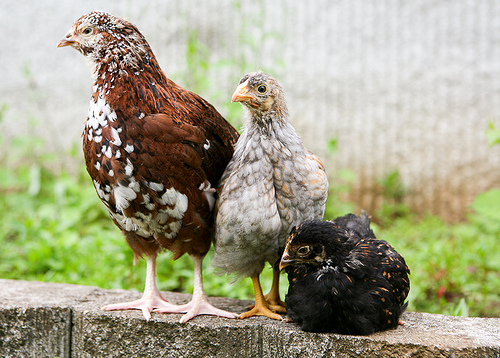<image>
Can you confirm if the chicken is to the right of the chicken? Yes. From this viewpoint, the chicken is positioned to the right side relative to the chicken. 